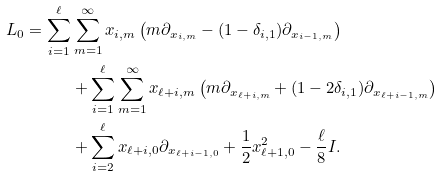<formula> <loc_0><loc_0><loc_500><loc_500>L _ { 0 } = \sum _ { i = 1 } ^ { \ell } & \sum _ { m = 1 } ^ { \infty } x _ { i , m } \left ( m \partial _ { x _ { i , m } } - ( 1 - \delta _ { i , 1 } ) \partial _ { x _ { i - 1 , m } } \right ) \\ & + \sum _ { i = 1 } ^ { \ell } \sum _ { m = 1 } ^ { \infty } x _ { \ell + i , m } \left ( m \partial _ { x _ { \ell + i , m } } + ( 1 - 2 \delta _ { i , 1 } ) \partial _ { x _ { \ell + i - 1 , m } } \right ) \\ & + \sum _ { i = 2 } ^ { \ell } x _ { \ell + i , 0 } \partial _ { x _ { \ell + i - 1 , 0 } } + \frac { 1 } { 2 } x _ { \ell + 1 , 0 } ^ { 2 } - \frac { \ell } { 8 } I .</formula> 